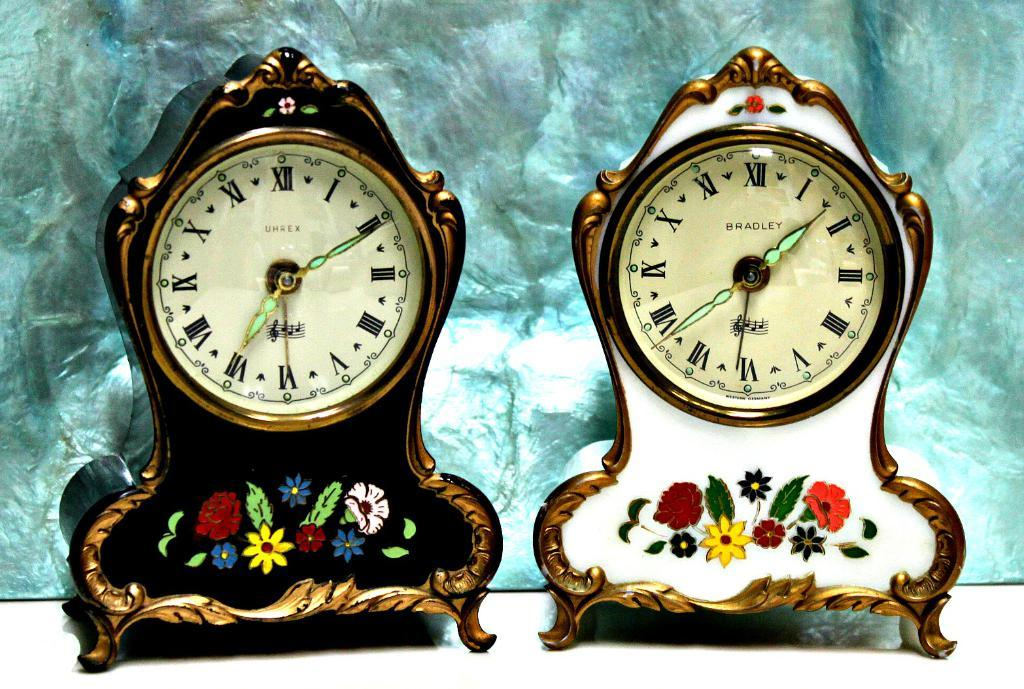Provide a one-sentence caption for the provided image. An old UHREX clock next to an old BRADLEY clock. 